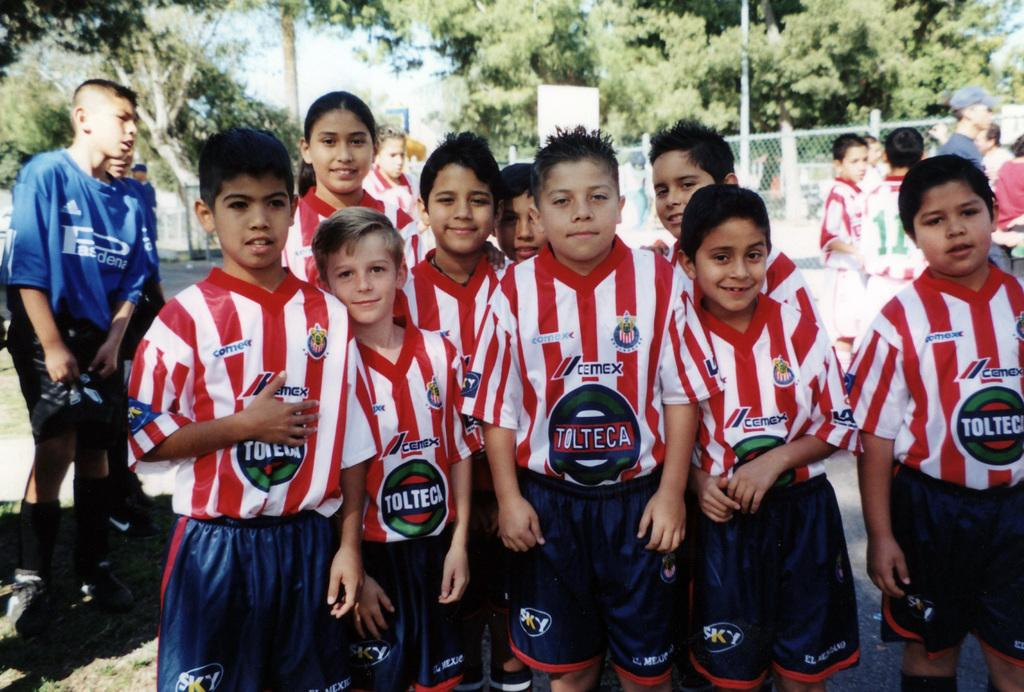<image>
Give a short and clear explanation of the subsequent image. A young soccer team sponsored by Tolteca gather together outside. 